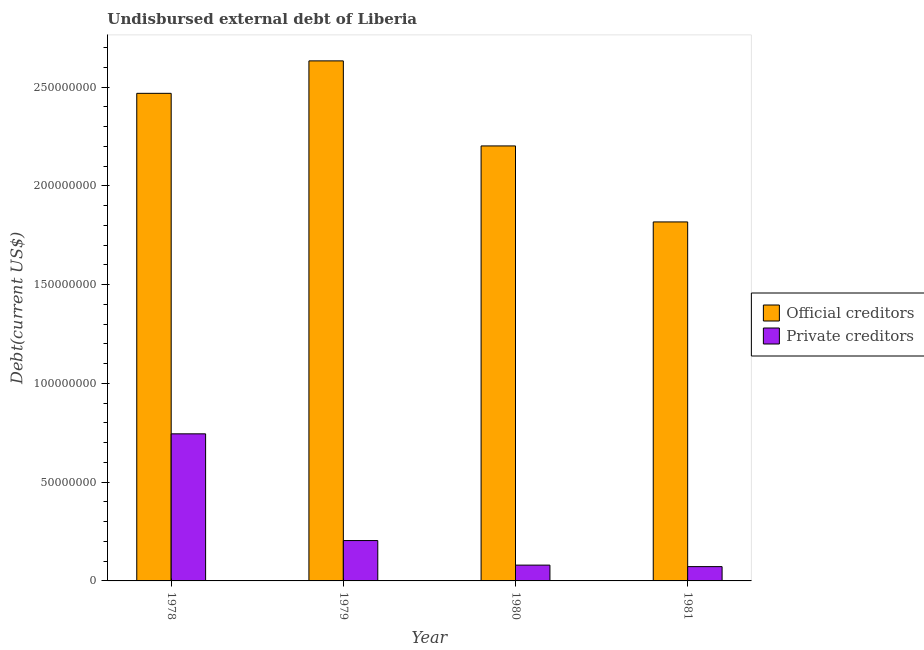How many different coloured bars are there?
Offer a terse response. 2. How many groups of bars are there?
Ensure brevity in your answer.  4. Are the number of bars per tick equal to the number of legend labels?
Your answer should be very brief. Yes. Are the number of bars on each tick of the X-axis equal?
Make the answer very short. Yes. How many bars are there on the 1st tick from the left?
Provide a short and direct response. 2. What is the label of the 1st group of bars from the left?
Offer a terse response. 1978. In how many cases, is the number of bars for a given year not equal to the number of legend labels?
Your answer should be very brief. 0. What is the undisbursed external debt of private creditors in 1979?
Make the answer very short. 2.04e+07. Across all years, what is the maximum undisbursed external debt of official creditors?
Offer a very short reply. 2.63e+08. Across all years, what is the minimum undisbursed external debt of official creditors?
Your response must be concise. 1.82e+08. In which year was the undisbursed external debt of private creditors maximum?
Make the answer very short. 1978. What is the total undisbursed external debt of official creditors in the graph?
Offer a very short reply. 9.12e+08. What is the difference between the undisbursed external debt of private creditors in 1978 and that in 1980?
Make the answer very short. 6.65e+07. What is the difference between the undisbursed external debt of official creditors in 1979 and the undisbursed external debt of private creditors in 1981?
Provide a short and direct response. 8.15e+07. What is the average undisbursed external debt of private creditors per year?
Offer a terse response. 2.75e+07. In how many years, is the undisbursed external debt of official creditors greater than 250000000 US$?
Make the answer very short. 1. What is the ratio of the undisbursed external debt of official creditors in 1978 to that in 1980?
Provide a succinct answer. 1.12. Is the undisbursed external debt of private creditors in 1979 less than that in 1981?
Your response must be concise. No. What is the difference between the highest and the second highest undisbursed external debt of private creditors?
Your response must be concise. 5.40e+07. What is the difference between the highest and the lowest undisbursed external debt of private creditors?
Ensure brevity in your answer.  6.72e+07. In how many years, is the undisbursed external debt of official creditors greater than the average undisbursed external debt of official creditors taken over all years?
Your response must be concise. 2. What does the 2nd bar from the left in 1979 represents?
Ensure brevity in your answer.  Private creditors. What does the 2nd bar from the right in 1980 represents?
Your response must be concise. Official creditors. How many bars are there?
Provide a short and direct response. 8. How many years are there in the graph?
Make the answer very short. 4. What is the difference between two consecutive major ticks on the Y-axis?
Offer a terse response. 5.00e+07. Are the values on the major ticks of Y-axis written in scientific E-notation?
Keep it short and to the point. No. Does the graph contain any zero values?
Offer a terse response. No. How many legend labels are there?
Provide a short and direct response. 2. What is the title of the graph?
Give a very brief answer. Undisbursed external debt of Liberia. What is the label or title of the Y-axis?
Provide a succinct answer. Debt(current US$). What is the Debt(current US$) in Official creditors in 1978?
Give a very brief answer. 2.47e+08. What is the Debt(current US$) of Private creditors in 1978?
Keep it short and to the point. 7.45e+07. What is the Debt(current US$) in Official creditors in 1979?
Give a very brief answer. 2.63e+08. What is the Debt(current US$) of Private creditors in 1979?
Your answer should be compact. 2.04e+07. What is the Debt(current US$) of Official creditors in 1980?
Your response must be concise. 2.20e+08. What is the Debt(current US$) of Official creditors in 1981?
Offer a very short reply. 1.82e+08. What is the Debt(current US$) in Private creditors in 1981?
Offer a very short reply. 7.24e+06. Across all years, what is the maximum Debt(current US$) in Official creditors?
Provide a short and direct response. 2.63e+08. Across all years, what is the maximum Debt(current US$) of Private creditors?
Provide a short and direct response. 7.45e+07. Across all years, what is the minimum Debt(current US$) in Official creditors?
Your answer should be compact. 1.82e+08. Across all years, what is the minimum Debt(current US$) of Private creditors?
Keep it short and to the point. 7.24e+06. What is the total Debt(current US$) of Official creditors in the graph?
Offer a terse response. 9.12e+08. What is the total Debt(current US$) in Private creditors in the graph?
Provide a succinct answer. 1.10e+08. What is the difference between the Debt(current US$) in Official creditors in 1978 and that in 1979?
Provide a succinct answer. -1.64e+07. What is the difference between the Debt(current US$) in Private creditors in 1978 and that in 1979?
Ensure brevity in your answer.  5.40e+07. What is the difference between the Debt(current US$) in Official creditors in 1978 and that in 1980?
Your answer should be compact. 2.66e+07. What is the difference between the Debt(current US$) of Private creditors in 1978 and that in 1980?
Offer a very short reply. 6.65e+07. What is the difference between the Debt(current US$) of Official creditors in 1978 and that in 1981?
Keep it short and to the point. 6.51e+07. What is the difference between the Debt(current US$) of Private creditors in 1978 and that in 1981?
Provide a short and direct response. 6.72e+07. What is the difference between the Debt(current US$) of Official creditors in 1979 and that in 1980?
Your response must be concise. 4.31e+07. What is the difference between the Debt(current US$) of Private creditors in 1979 and that in 1980?
Your answer should be very brief. 1.24e+07. What is the difference between the Debt(current US$) of Official creditors in 1979 and that in 1981?
Keep it short and to the point. 8.15e+07. What is the difference between the Debt(current US$) of Private creditors in 1979 and that in 1981?
Offer a terse response. 1.32e+07. What is the difference between the Debt(current US$) in Official creditors in 1980 and that in 1981?
Your answer should be very brief. 3.85e+07. What is the difference between the Debt(current US$) in Private creditors in 1980 and that in 1981?
Provide a succinct answer. 7.58e+05. What is the difference between the Debt(current US$) of Official creditors in 1978 and the Debt(current US$) of Private creditors in 1979?
Offer a very short reply. 2.26e+08. What is the difference between the Debt(current US$) in Official creditors in 1978 and the Debt(current US$) in Private creditors in 1980?
Your response must be concise. 2.39e+08. What is the difference between the Debt(current US$) of Official creditors in 1978 and the Debt(current US$) of Private creditors in 1981?
Your answer should be very brief. 2.40e+08. What is the difference between the Debt(current US$) in Official creditors in 1979 and the Debt(current US$) in Private creditors in 1980?
Make the answer very short. 2.55e+08. What is the difference between the Debt(current US$) of Official creditors in 1979 and the Debt(current US$) of Private creditors in 1981?
Ensure brevity in your answer.  2.56e+08. What is the difference between the Debt(current US$) of Official creditors in 1980 and the Debt(current US$) of Private creditors in 1981?
Provide a succinct answer. 2.13e+08. What is the average Debt(current US$) of Official creditors per year?
Keep it short and to the point. 2.28e+08. What is the average Debt(current US$) of Private creditors per year?
Your response must be concise. 2.75e+07. In the year 1978, what is the difference between the Debt(current US$) of Official creditors and Debt(current US$) of Private creditors?
Your answer should be compact. 1.72e+08. In the year 1979, what is the difference between the Debt(current US$) of Official creditors and Debt(current US$) of Private creditors?
Provide a succinct answer. 2.43e+08. In the year 1980, what is the difference between the Debt(current US$) in Official creditors and Debt(current US$) in Private creditors?
Your answer should be very brief. 2.12e+08. In the year 1981, what is the difference between the Debt(current US$) in Official creditors and Debt(current US$) in Private creditors?
Offer a very short reply. 1.74e+08. What is the ratio of the Debt(current US$) in Official creditors in 1978 to that in 1979?
Keep it short and to the point. 0.94. What is the ratio of the Debt(current US$) in Private creditors in 1978 to that in 1979?
Provide a short and direct response. 3.64. What is the ratio of the Debt(current US$) in Official creditors in 1978 to that in 1980?
Your answer should be compact. 1.12. What is the ratio of the Debt(current US$) in Private creditors in 1978 to that in 1980?
Ensure brevity in your answer.  9.31. What is the ratio of the Debt(current US$) of Official creditors in 1978 to that in 1981?
Your answer should be very brief. 1.36. What is the ratio of the Debt(current US$) in Private creditors in 1978 to that in 1981?
Ensure brevity in your answer.  10.28. What is the ratio of the Debt(current US$) of Official creditors in 1979 to that in 1980?
Your answer should be very brief. 1.2. What is the ratio of the Debt(current US$) of Private creditors in 1979 to that in 1980?
Ensure brevity in your answer.  2.55. What is the ratio of the Debt(current US$) in Official creditors in 1979 to that in 1981?
Your answer should be compact. 1.45. What is the ratio of the Debt(current US$) in Private creditors in 1979 to that in 1981?
Keep it short and to the point. 2.82. What is the ratio of the Debt(current US$) of Official creditors in 1980 to that in 1981?
Your answer should be compact. 1.21. What is the ratio of the Debt(current US$) of Private creditors in 1980 to that in 1981?
Offer a terse response. 1.1. What is the difference between the highest and the second highest Debt(current US$) in Official creditors?
Your answer should be very brief. 1.64e+07. What is the difference between the highest and the second highest Debt(current US$) of Private creditors?
Offer a very short reply. 5.40e+07. What is the difference between the highest and the lowest Debt(current US$) in Official creditors?
Provide a short and direct response. 8.15e+07. What is the difference between the highest and the lowest Debt(current US$) in Private creditors?
Provide a short and direct response. 6.72e+07. 